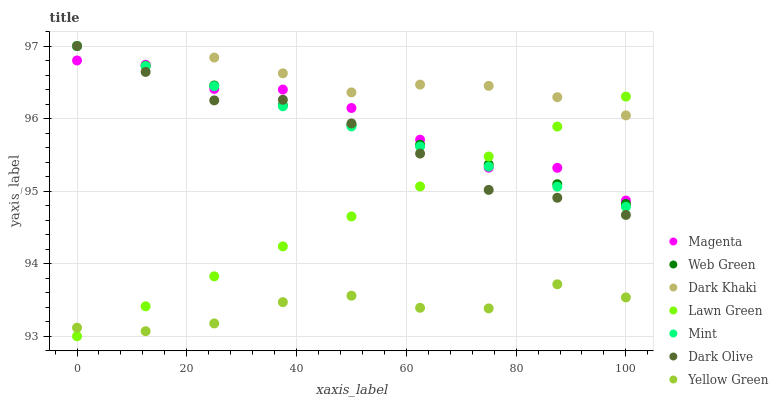Does Yellow Green have the minimum area under the curve?
Answer yes or no. Yes. Does Dark Khaki have the maximum area under the curve?
Answer yes or no. Yes. Does Dark Olive have the minimum area under the curve?
Answer yes or no. No. Does Dark Olive have the maximum area under the curve?
Answer yes or no. No. Is Web Green the smoothest?
Answer yes or no. Yes. Is Magenta the roughest?
Answer yes or no. Yes. Is Yellow Green the smoothest?
Answer yes or no. No. Is Yellow Green the roughest?
Answer yes or no. No. Does Lawn Green have the lowest value?
Answer yes or no. Yes. Does Yellow Green have the lowest value?
Answer yes or no. No. Does Mint have the highest value?
Answer yes or no. Yes. Does Yellow Green have the highest value?
Answer yes or no. No. Is Yellow Green less than Dark Khaki?
Answer yes or no. Yes. Is Dark Khaki greater than Yellow Green?
Answer yes or no. Yes. Does Dark Khaki intersect Magenta?
Answer yes or no. Yes. Is Dark Khaki less than Magenta?
Answer yes or no. No. Is Dark Khaki greater than Magenta?
Answer yes or no. No. Does Yellow Green intersect Dark Khaki?
Answer yes or no. No. 